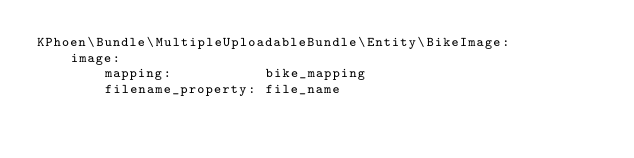Convert code to text. <code><loc_0><loc_0><loc_500><loc_500><_YAML_>KPhoen\Bundle\MultipleUploadableBundle\Entity\BikeImage:
    image:
        mapping:           bike_mapping
        filename_property: file_name
</code> 